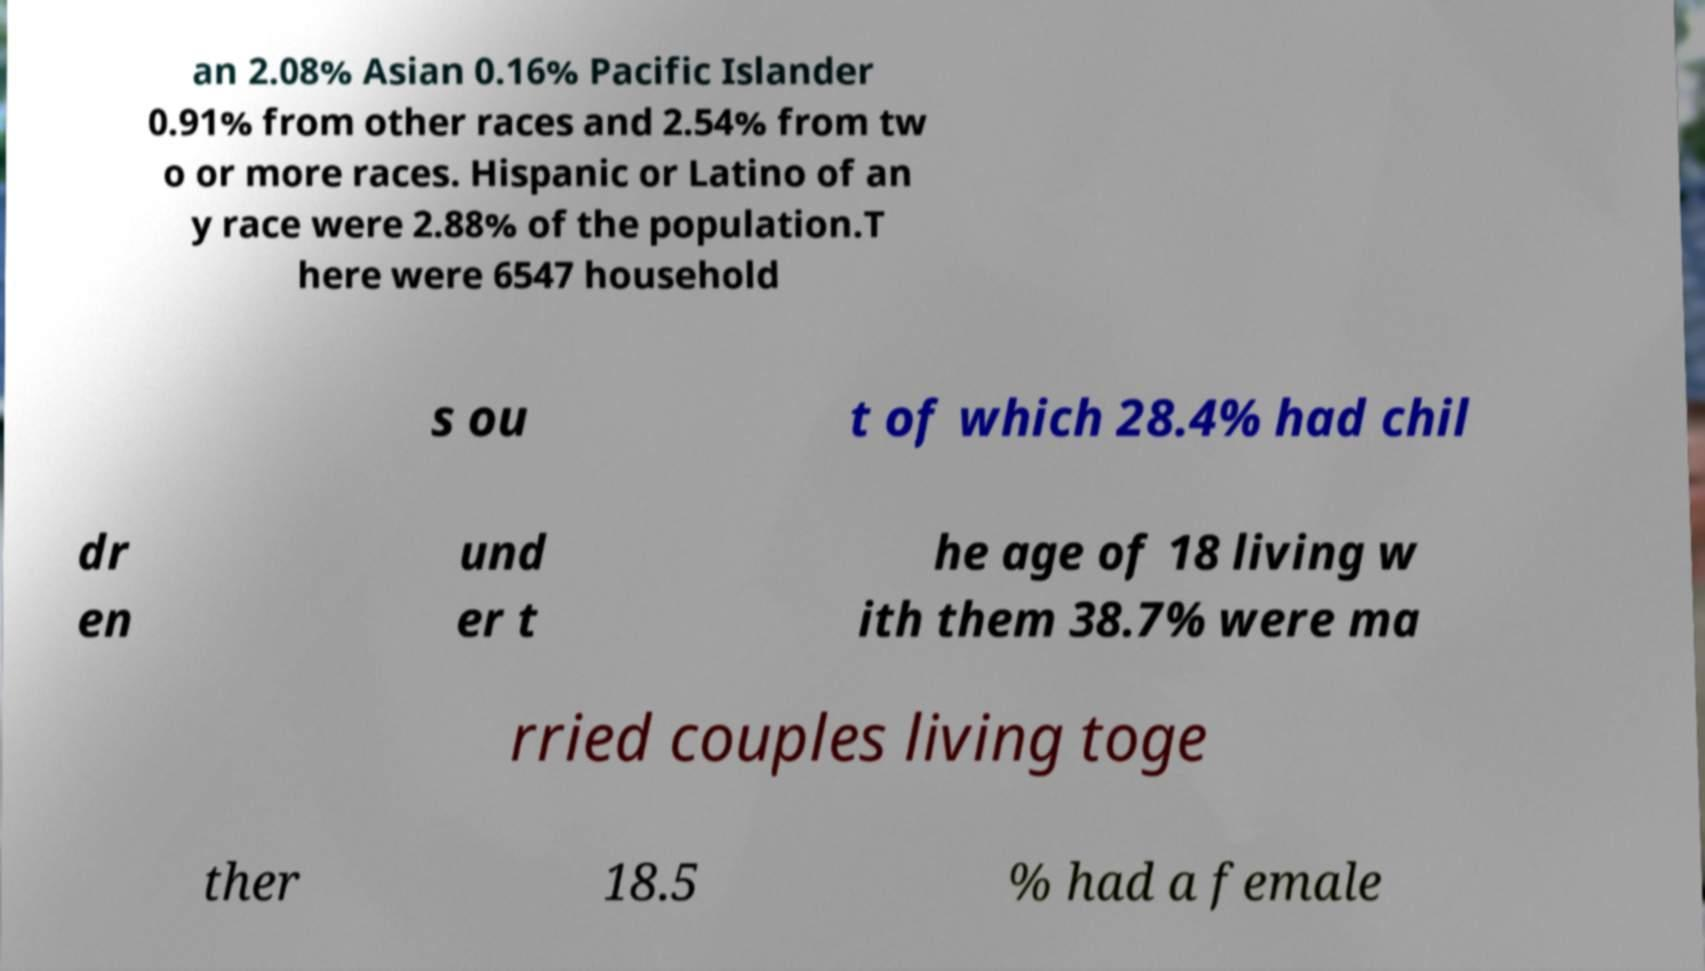I need the written content from this picture converted into text. Can you do that? an 2.08% Asian 0.16% Pacific Islander 0.91% from other races and 2.54% from tw o or more races. Hispanic or Latino of an y race were 2.88% of the population.T here were 6547 household s ou t of which 28.4% had chil dr en und er t he age of 18 living w ith them 38.7% were ma rried couples living toge ther 18.5 % had a female 